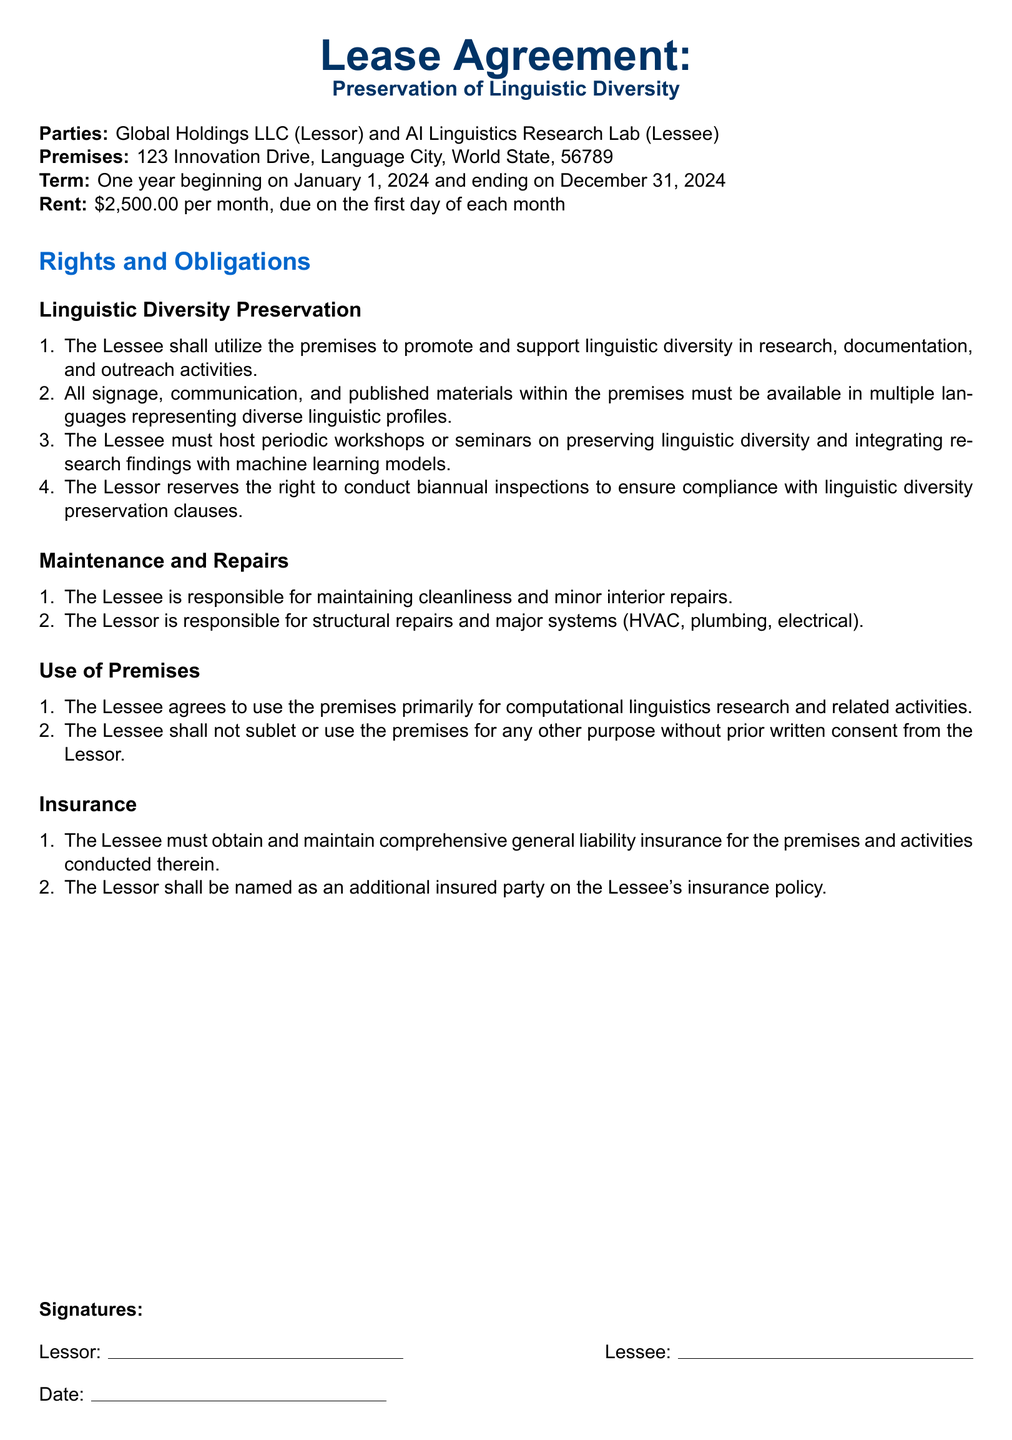What is the name of the lessor? The lessor is Global Holdings LLC as stated at the beginning of the document.
Answer: Global Holdings LLC What is the monthly rent for the premises? The monthly rent is listed as $2,500.00, made clear in the Rent section of the lease.
Answer: $2,500.00 What is the term duration of the lease? The term duration is specified as one year, starting January 1, 2024, and ending December 31, 2024.
Answer: One year What must all signage and communication include? The document specifies that all signage and communication must be available in multiple languages.
Answer: Multiple languages How often can the lessor conduct inspections? According to the document, the lessor can conduct inspections biannually to ensure compliance.
Answer: Biannual What must the lessee host periodically? The lessee is required to host periodic workshops or seminars on preserving linguistic diversity.
Answer: Workshops or seminars Who is responsible for structural repairs? The lessor is responsible for structural repairs, as mentioned in the Maintenance and Repairs section.
Answer: Lessor Is the lessee allowed to sublet the premises? The lessee cannot sublet without prior written consent from the lessor, as outlined in the Use of Premises section.
Answer: No What type of insurance must the lessee maintain? The lessee must obtain comprehensive general liability insurance for the premises and activities.
Answer: Comprehensive general liability insurance 